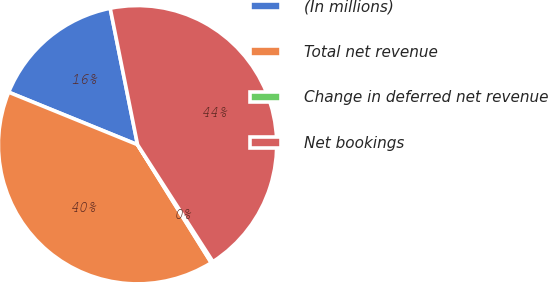Convert chart to OTSL. <chart><loc_0><loc_0><loc_500><loc_500><pie_chart><fcel>(In millions)<fcel>Total net revenue<fcel>Change in deferred net revenue<fcel>Net bookings<nl><fcel>15.69%<fcel>40.04%<fcel>0.23%<fcel>44.04%<nl></chart> 